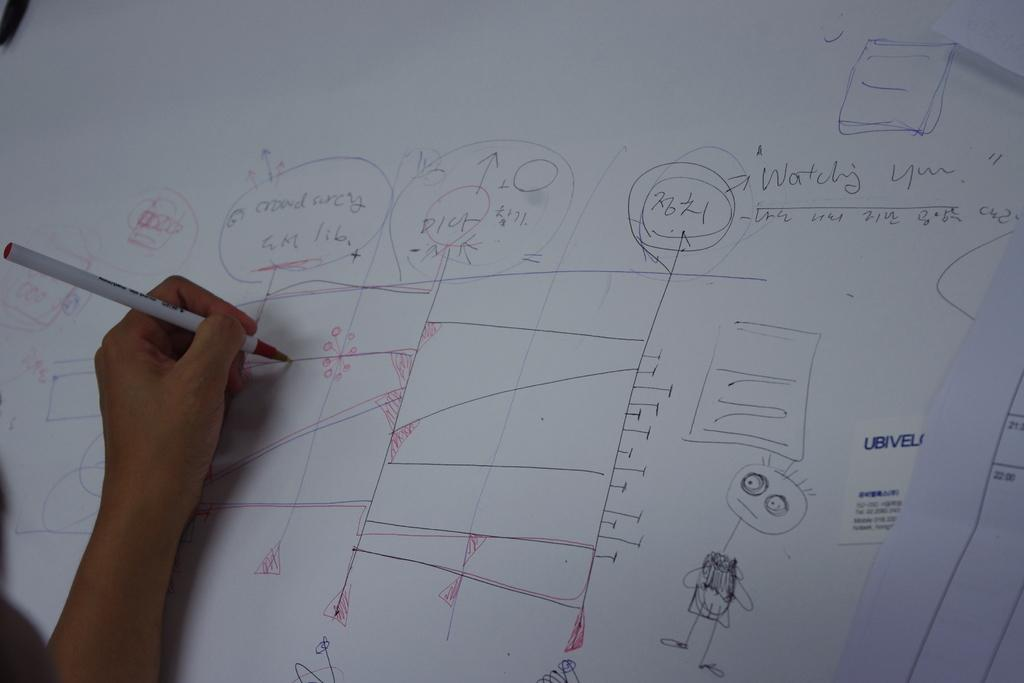<image>
Present a compact description of the photo's key features. A person drawing a complex design with the words "watching you" written on the paper. 